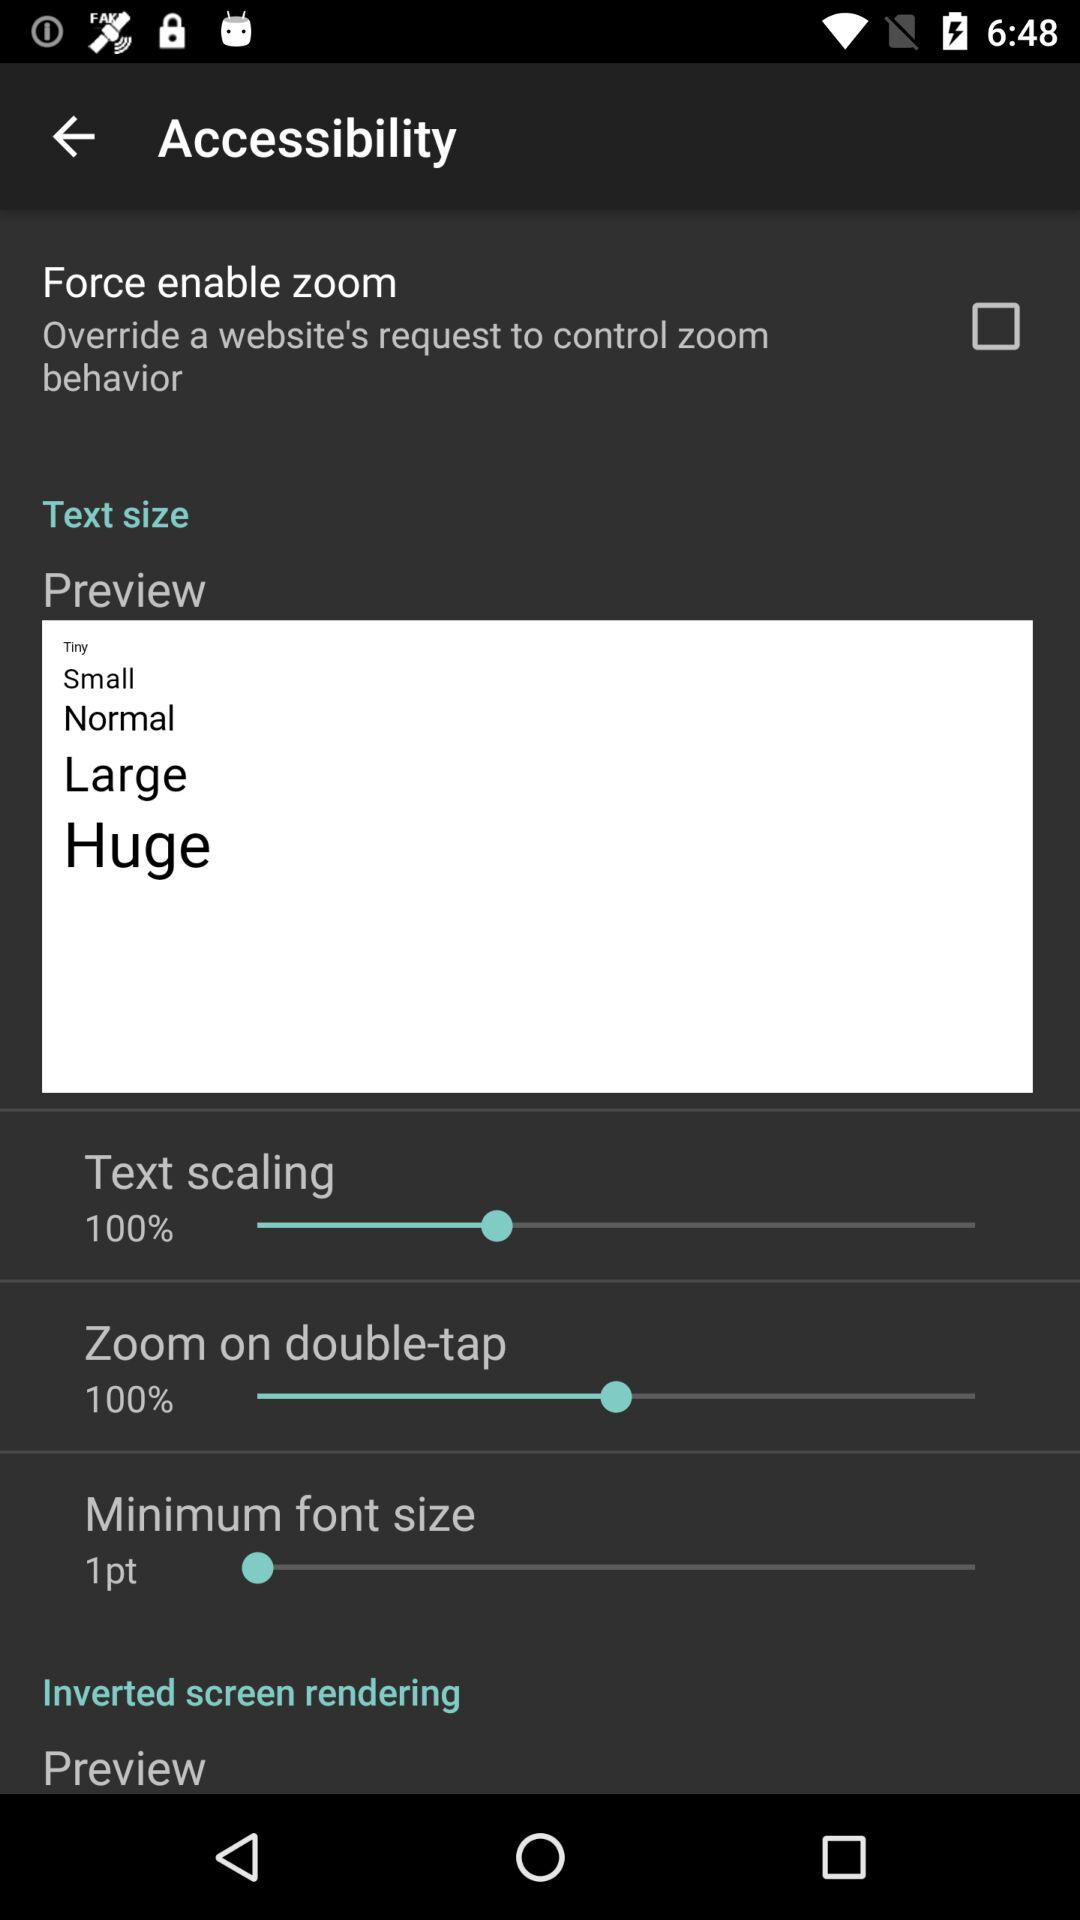How many text size options are there?
Answer the question using a single word or phrase. 5 